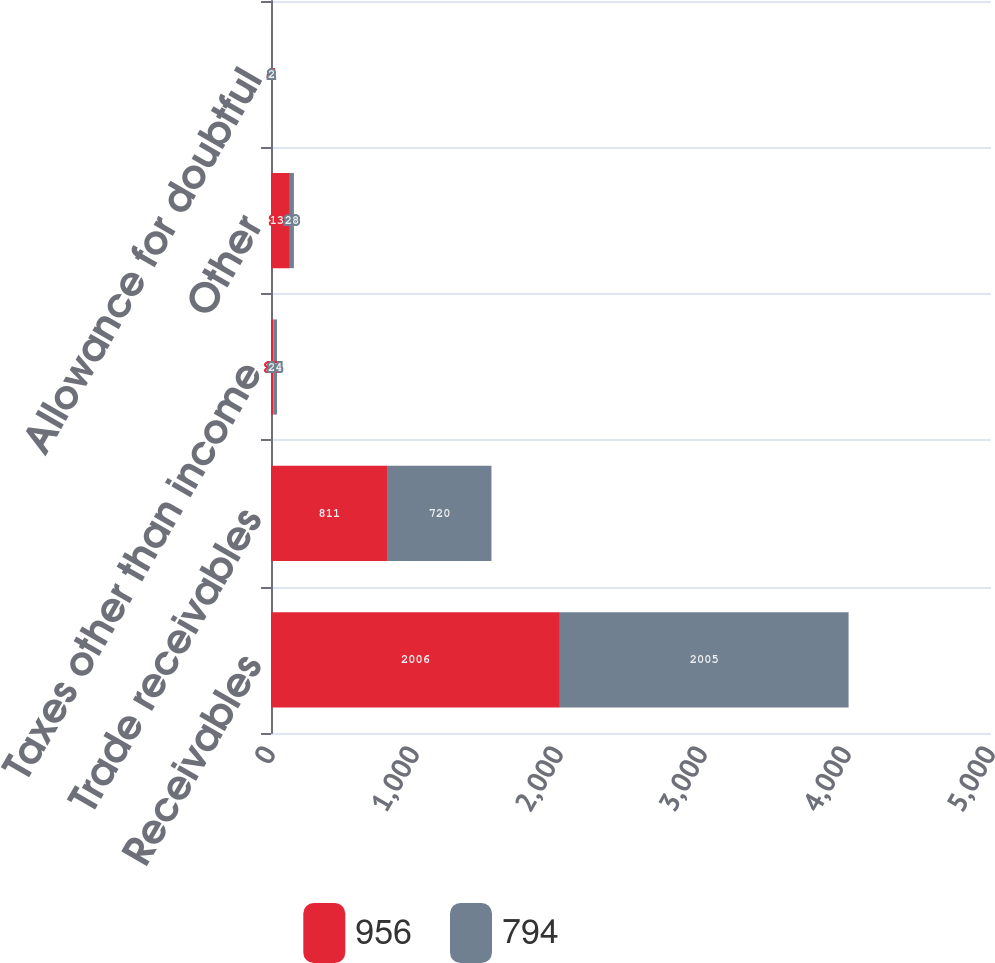Convert chart. <chart><loc_0><loc_0><loc_500><loc_500><stacked_bar_chart><ecel><fcel>Receivables<fcel>Trade receivables<fcel>Taxes other than income<fcel>Other<fcel>Allowance for doubtful<nl><fcel>956<fcel>2006<fcel>811<fcel>18<fcel>131<fcel>4<nl><fcel>794<fcel>2005<fcel>720<fcel>24<fcel>28<fcel>2<nl></chart> 